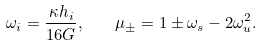Convert formula to latex. <formula><loc_0><loc_0><loc_500><loc_500>\omega _ { i } = \frac { \kappa h _ { i } } { 1 6 G } , \quad \mu _ { \pm } = 1 \pm \omega _ { s } - 2 \omega _ { u } ^ { 2 } .</formula> 